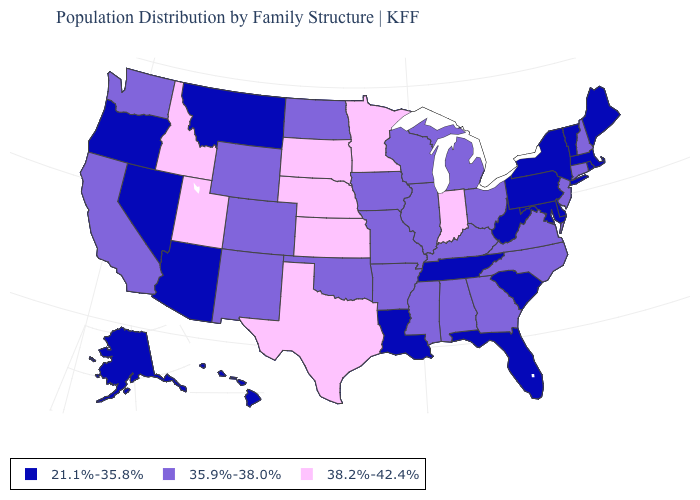Name the states that have a value in the range 21.1%-35.8%?
Give a very brief answer. Alaska, Arizona, Delaware, Florida, Hawaii, Louisiana, Maine, Maryland, Massachusetts, Montana, Nevada, New York, Oregon, Pennsylvania, Rhode Island, South Carolina, Tennessee, Vermont, West Virginia. Name the states that have a value in the range 38.2%-42.4%?
Write a very short answer. Idaho, Indiana, Kansas, Minnesota, Nebraska, South Dakota, Texas, Utah. What is the value of Arizona?
Concise answer only. 21.1%-35.8%. Among the states that border Nebraska , which have the lowest value?
Short answer required. Colorado, Iowa, Missouri, Wyoming. Name the states that have a value in the range 35.9%-38.0%?
Short answer required. Alabama, Arkansas, California, Colorado, Connecticut, Georgia, Illinois, Iowa, Kentucky, Michigan, Mississippi, Missouri, New Hampshire, New Jersey, New Mexico, North Carolina, North Dakota, Ohio, Oklahoma, Virginia, Washington, Wisconsin, Wyoming. What is the value of Pennsylvania?
Quick response, please. 21.1%-35.8%. What is the value of Arkansas?
Concise answer only. 35.9%-38.0%. What is the highest value in states that border Kentucky?
Short answer required. 38.2%-42.4%. Name the states that have a value in the range 38.2%-42.4%?
Keep it brief. Idaho, Indiana, Kansas, Minnesota, Nebraska, South Dakota, Texas, Utah. What is the value of Delaware?
Short answer required. 21.1%-35.8%. Name the states that have a value in the range 21.1%-35.8%?
Short answer required. Alaska, Arizona, Delaware, Florida, Hawaii, Louisiana, Maine, Maryland, Massachusetts, Montana, Nevada, New York, Oregon, Pennsylvania, Rhode Island, South Carolina, Tennessee, Vermont, West Virginia. Name the states that have a value in the range 35.9%-38.0%?
Write a very short answer. Alabama, Arkansas, California, Colorado, Connecticut, Georgia, Illinois, Iowa, Kentucky, Michigan, Mississippi, Missouri, New Hampshire, New Jersey, New Mexico, North Carolina, North Dakota, Ohio, Oklahoma, Virginia, Washington, Wisconsin, Wyoming. Does New Hampshire have the same value as Mississippi?
Give a very brief answer. Yes. Name the states that have a value in the range 38.2%-42.4%?
Keep it brief. Idaho, Indiana, Kansas, Minnesota, Nebraska, South Dakota, Texas, Utah. Name the states that have a value in the range 21.1%-35.8%?
Concise answer only. Alaska, Arizona, Delaware, Florida, Hawaii, Louisiana, Maine, Maryland, Massachusetts, Montana, Nevada, New York, Oregon, Pennsylvania, Rhode Island, South Carolina, Tennessee, Vermont, West Virginia. 